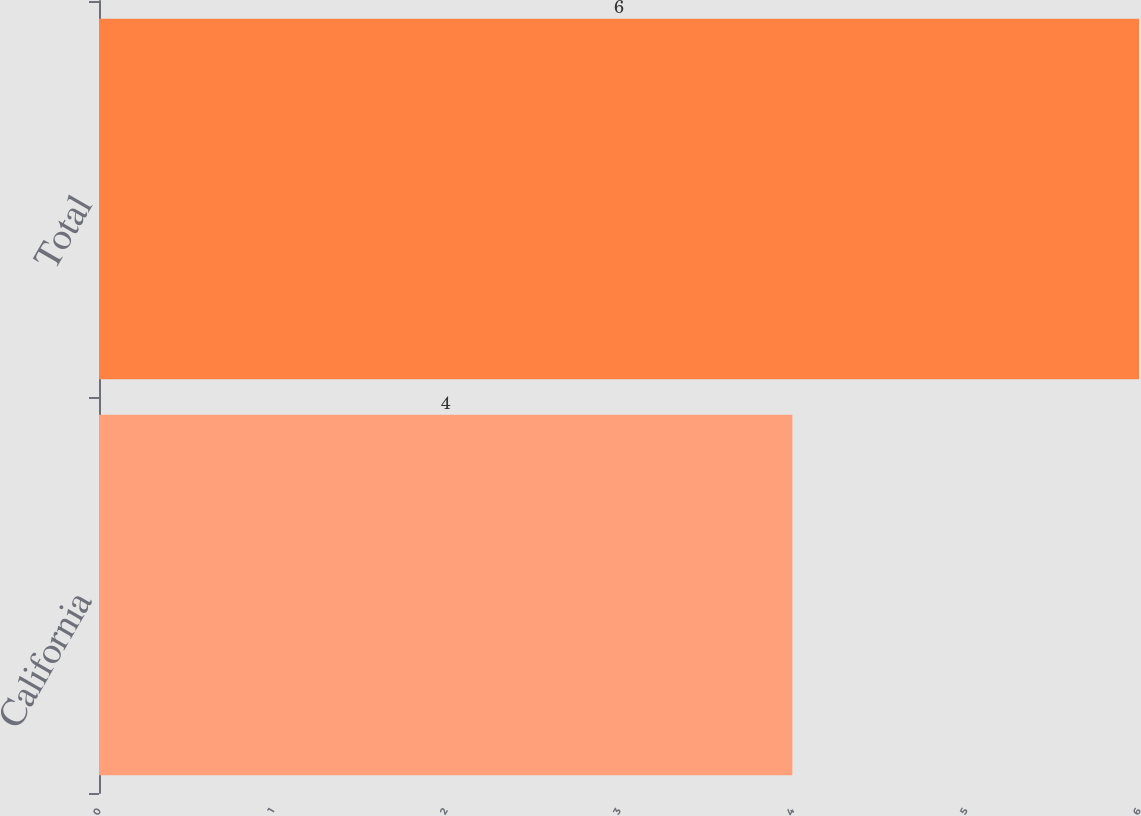Convert chart. <chart><loc_0><loc_0><loc_500><loc_500><bar_chart><fcel>California<fcel>Total<nl><fcel>4<fcel>6<nl></chart> 